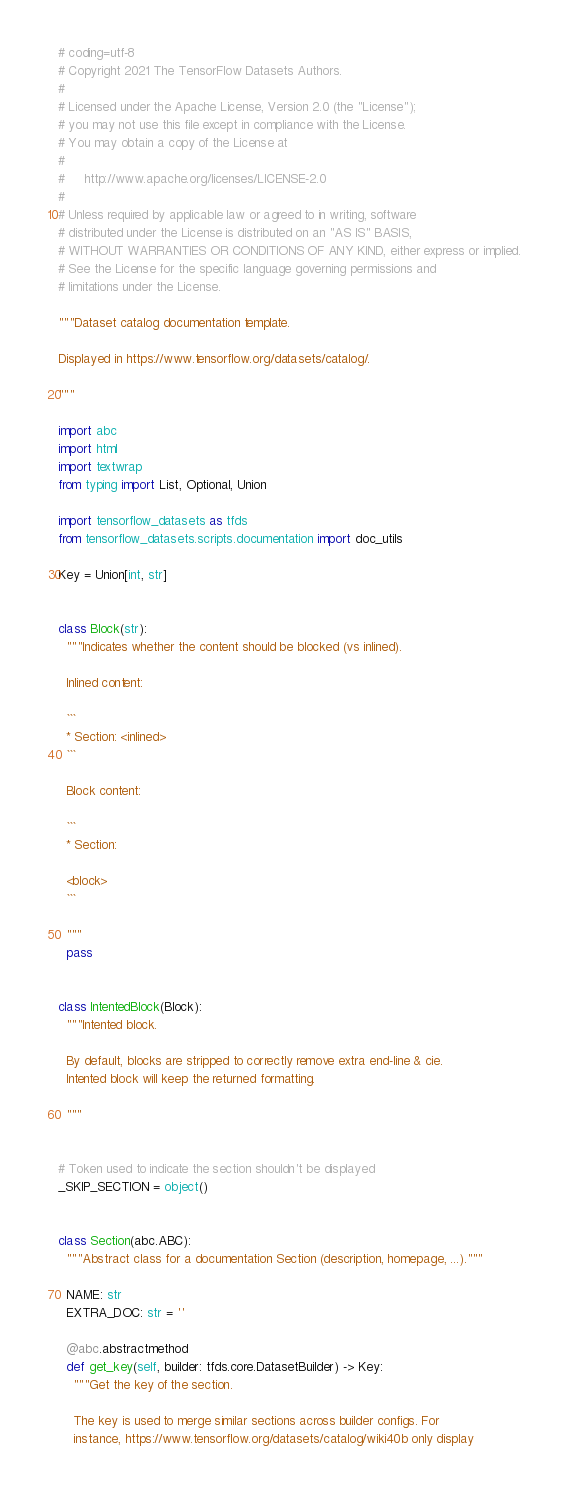Convert code to text. <code><loc_0><loc_0><loc_500><loc_500><_Python_># coding=utf-8
# Copyright 2021 The TensorFlow Datasets Authors.
#
# Licensed under the Apache License, Version 2.0 (the "License");
# you may not use this file except in compliance with the License.
# You may obtain a copy of the License at
#
#     http://www.apache.org/licenses/LICENSE-2.0
#
# Unless required by applicable law or agreed to in writing, software
# distributed under the License is distributed on an "AS IS" BASIS,
# WITHOUT WARRANTIES OR CONDITIONS OF ANY KIND, either express or implied.
# See the License for the specific language governing permissions and
# limitations under the License.

"""Dataset catalog documentation template.

Displayed in https://www.tensorflow.org/datasets/catalog/.

"""

import abc
import html
import textwrap
from typing import List, Optional, Union

import tensorflow_datasets as tfds
from tensorflow_datasets.scripts.documentation import doc_utils

Key = Union[int, str]


class Block(str):
  """Indicates whether the content should be blocked (vs inlined).

  Inlined content:

  ```
  * Section: <inlined>
  ```

  Block content:

  ```
  * Section:

  <block>
  ```

  """
  pass


class IntentedBlock(Block):
  """Intented block.

  By default, blocks are stripped to correctly remove extra end-line & cie.
  Intented block will keep the returned formatting.

  """


# Token used to indicate the section shouldn't be displayed
_SKIP_SECTION = object()


class Section(abc.ABC):
  """Abstract class for a documentation Section (description, homepage, ...)."""

  NAME: str
  EXTRA_DOC: str = ''

  @abc.abstractmethod
  def get_key(self, builder: tfds.core.DatasetBuilder) -> Key:
    """Get the key of the section.

    The key is used to merge similar sections across builder configs. For
    instance, https://www.tensorflow.org/datasets/catalog/wiki40b only display</code> 